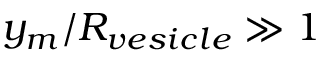<formula> <loc_0><loc_0><loc_500><loc_500>y _ { m } / R _ { v e s i c l e } \gg 1</formula> 